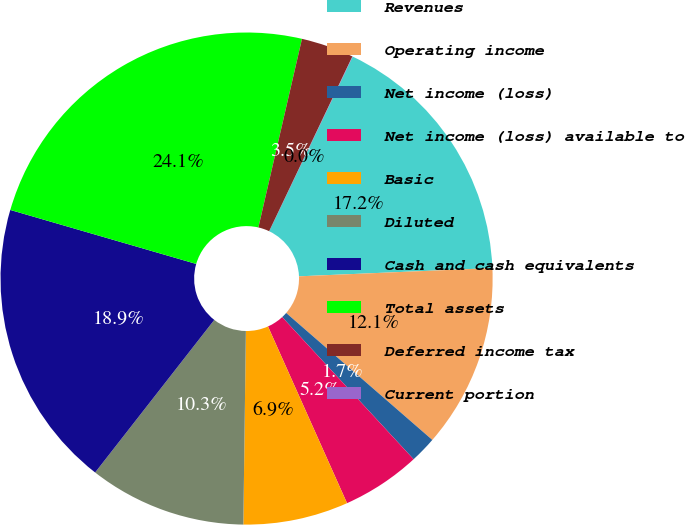<chart> <loc_0><loc_0><loc_500><loc_500><pie_chart><fcel>Revenues<fcel>Operating income<fcel>Net income (loss)<fcel>Net income (loss) available to<fcel>Basic<fcel>Diluted<fcel>Cash and cash equivalents<fcel>Total assets<fcel>Deferred income tax<fcel>Current portion<nl><fcel>17.22%<fcel>12.06%<fcel>1.74%<fcel>5.18%<fcel>6.9%<fcel>10.34%<fcel>18.94%<fcel>24.11%<fcel>3.46%<fcel>0.02%<nl></chart> 